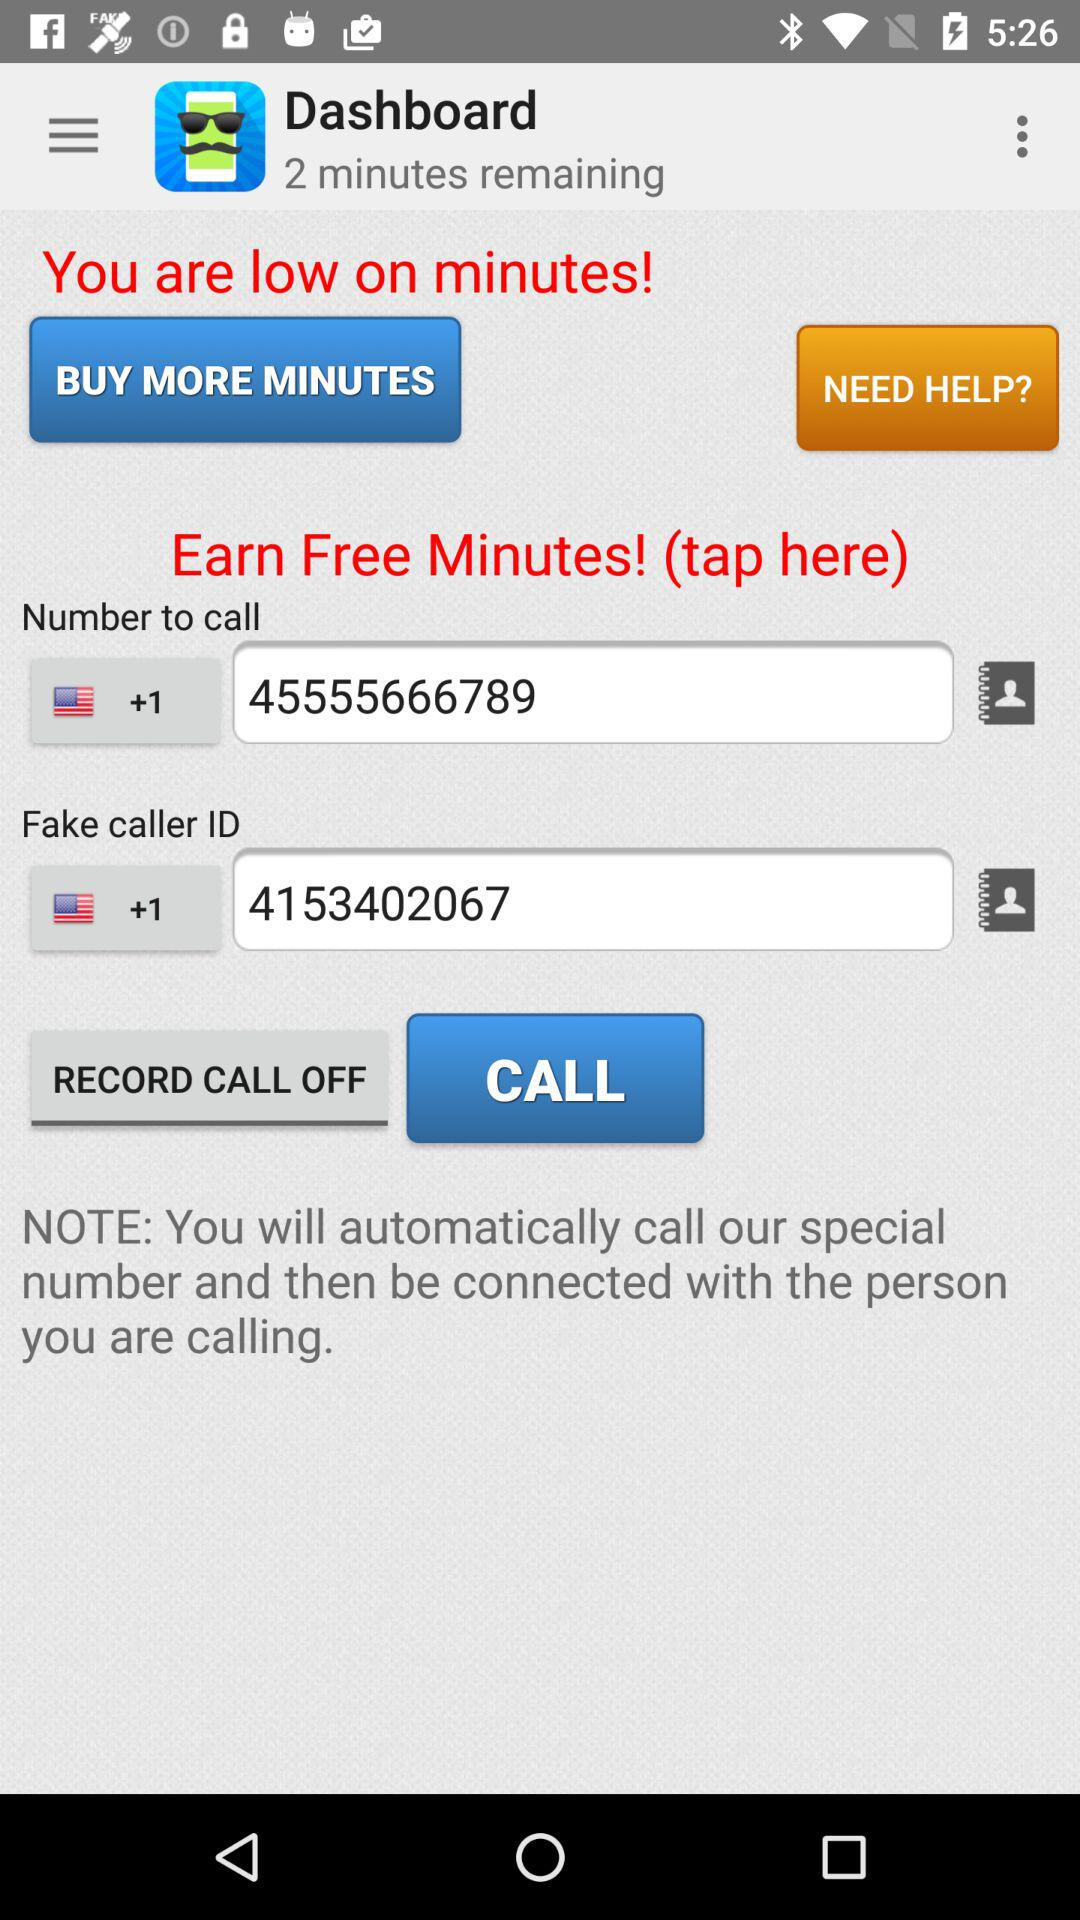How many minutes are remaining in the "Dashboard"? The number of remaining minutes in the "Dashboard" is 2. 